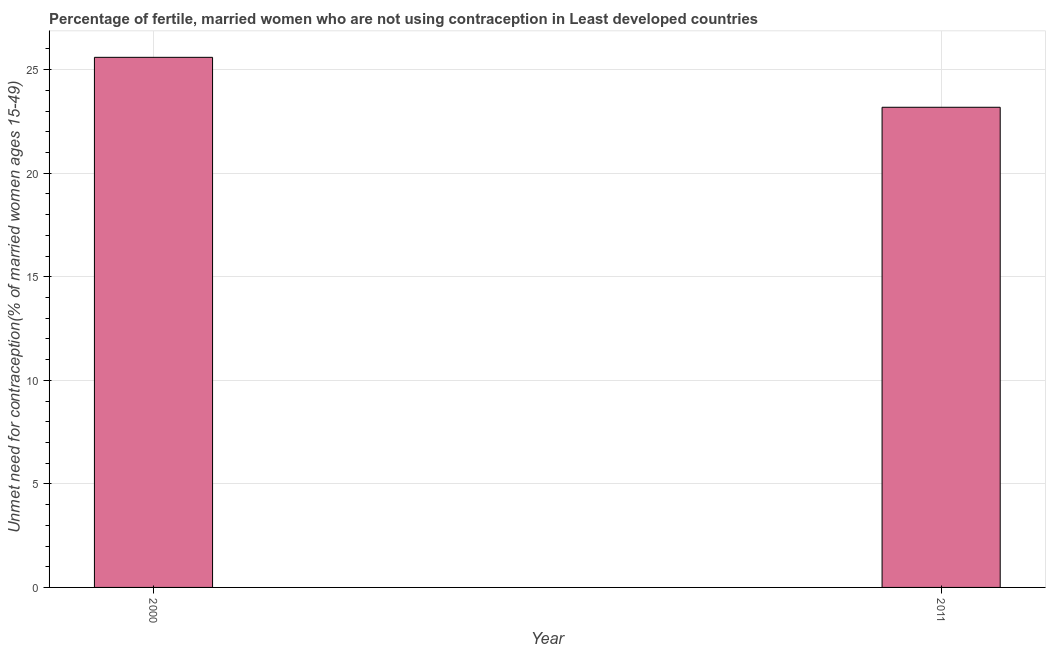What is the title of the graph?
Your answer should be very brief. Percentage of fertile, married women who are not using contraception in Least developed countries. What is the label or title of the Y-axis?
Provide a short and direct response.  Unmet need for contraception(% of married women ages 15-49). What is the number of married women who are not using contraception in 2011?
Offer a very short reply. 23.18. Across all years, what is the maximum number of married women who are not using contraception?
Your answer should be compact. 25.6. Across all years, what is the minimum number of married women who are not using contraception?
Your answer should be compact. 23.18. In which year was the number of married women who are not using contraception maximum?
Your answer should be very brief. 2000. What is the sum of the number of married women who are not using contraception?
Offer a very short reply. 48.78. What is the difference between the number of married women who are not using contraception in 2000 and 2011?
Your answer should be very brief. 2.41. What is the average number of married women who are not using contraception per year?
Provide a short and direct response. 24.39. What is the median number of married women who are not using contraception?
Your answer should be compact. 24.39. In how many years, is the number of married women who are not using contraception greater than 18 %?
Your answer should be very brief. 2. What is the ratio of the number of married women who are not using contraception in 2000 to that in 2011?
Keep it short and to the point. 1.1. Is the number of married women who are not using contraception in 2000 less than that in 2011?
Give a very brief answer. No. In how many years, is the number of married women who are not using contraception greater than the average number of married women who are not using contraception taken over all years?
Your response must be concise. 1. How many bars are there?
Keep it short and to the point. 2. What is the  Unmet need for contraception(% of married women ages 15-49) of 2000?
Your response must be concise. 25.6. What is the  Unmet need for contraception(% of married women ages 15-49) of 2011?
Provide a succinct answer. 23.18. What is the difference between the  Unmet need for contraception(% of married women ages 15-49) in 2000 and 2011?
Give a very brief answer. 2.41. What is the ratio of the  Unmet need for contraception(% of married women ages 15-49) in 2000 to that in 2011?
Keep it short and to the point. 1.1. 